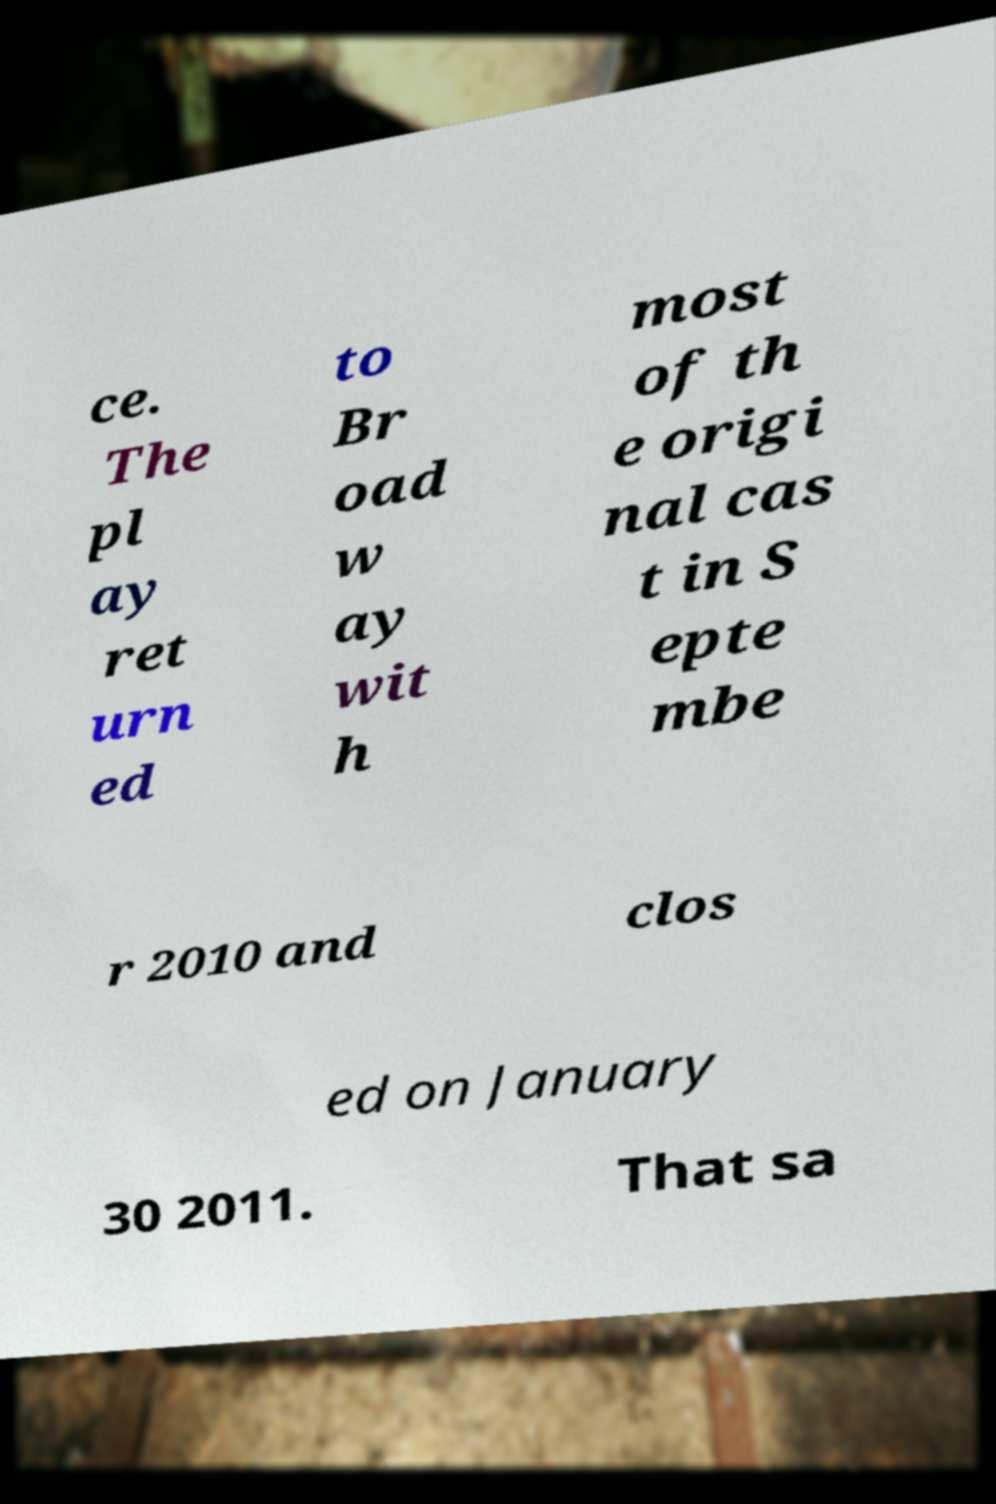Please read and relay the text visible in this image. What does it say? ce. The pl ay ret urn ed to Br oad w ay wit h most of th e origi nal cas t in S epte mbe r 2010 and clos ed on January 30 2011. That sa 